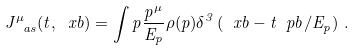Convert formula to latex. <formula><loc_0><loc_0><loc_500><loc_500>J ^ { \mu } _ { \ a s } ( t , \ x b ) = \int p \frac { p ^ { \mu } } { E _ { p } } \rho ( p ) \delta ^ { 3 } \left ( \ x b - t \ p b / E _ { p } \right ) \, .</formula> 